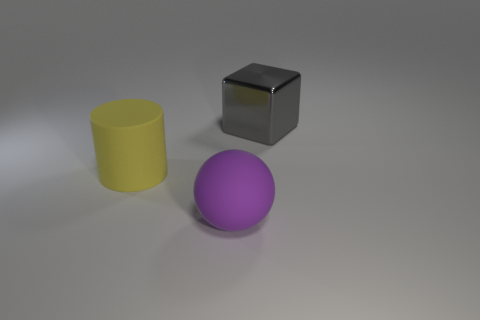Add 1 big purple rubber spheres. How many objects exist? 4 Subtract all balls. How many objects are left? 2 Add 2 cylinders. How many cylinders are left? 3 Add 1 blue shiny cylinders. How many blue shiny cylinders exist? 1 Subtract 1 gray cubes. How many objects are left? 2 Subtract all spheres. Subtract all yellow rubber objects. How many objects are left? 1 